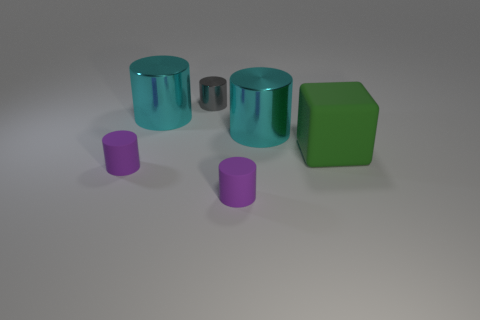Is the color of the tiny matte cylinder that is left of the small gray cylinder the same as the matte cylinder that is right of the tiny metal cylinder?
Offer a terse response. Yes. There is a purple rubber cylinder that is left of the small gray thing; what is its size?
Your answer should be compact. Small. There is a tiny object that is to the left of the small thing behind the matte block; how many purple cylinders are right of it?
Your answer should be very brief. 1. Do the rubber block and the tiny shiny cylinder have the same color?
Your answer should be very brief. No. How many objects are behind the big green thing and right of the gray cylinder?
Ensure brevity in your answer.  1. There is a small object that is behind the green rubber cube; what shape is it?
Provide a succinct answer. Cylinder. Are there fewer purple rubber cylinders that are right of the tiny gray thing than green matte things in front of the green rubber thing?
Offer a very short reply. No. Do the cyan cylinder left of the gray metallic thing and the small thing behind the green cube have the same material?
Your answer should be very brief. Yes. There is a small metal object; what shape is it?
Provide a succinct answer. Cylinder. Are there more large green rubber things that are on the left side of the green thing than tiny gray shiny cylinders that are in front of the small shiny object?
Offer a terse response. No. 